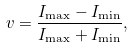<formula> <loc_0><loc_0><loc_500><loc_500>v = \frac { I _ { \max } - I _ { \min } } { I _ { \max } + I _ { \min } } ,</formula> 